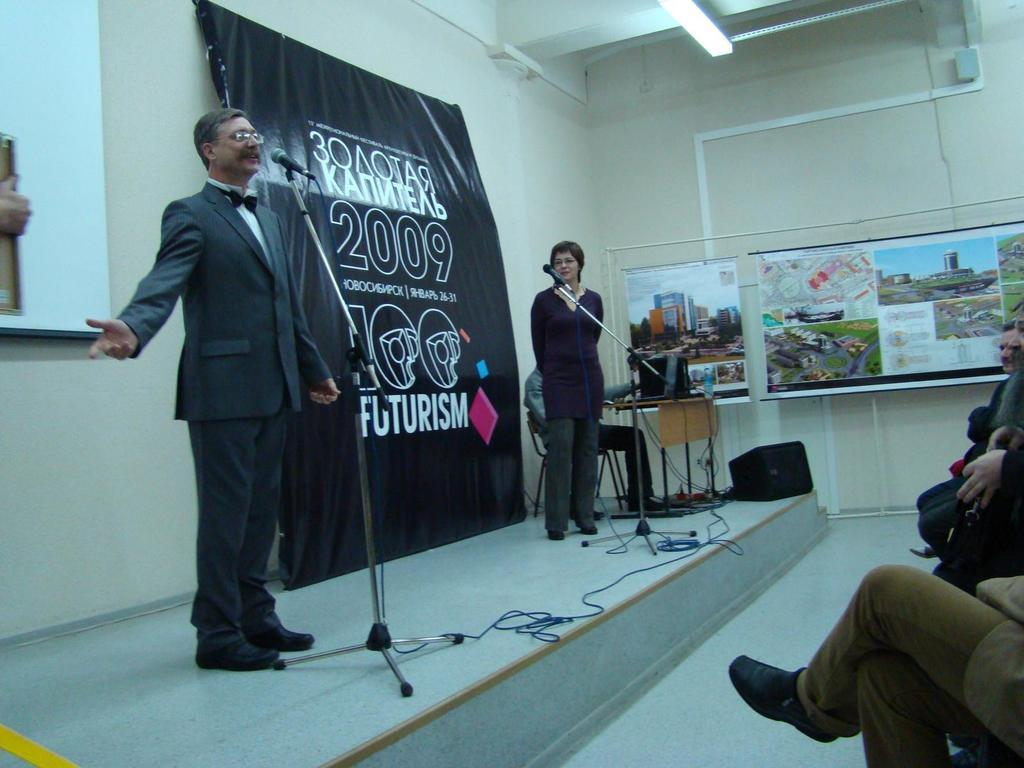<image>
Present a compact description of the photo's key features. Two people stand on a stage before a poster talking about 2009 and futurism 